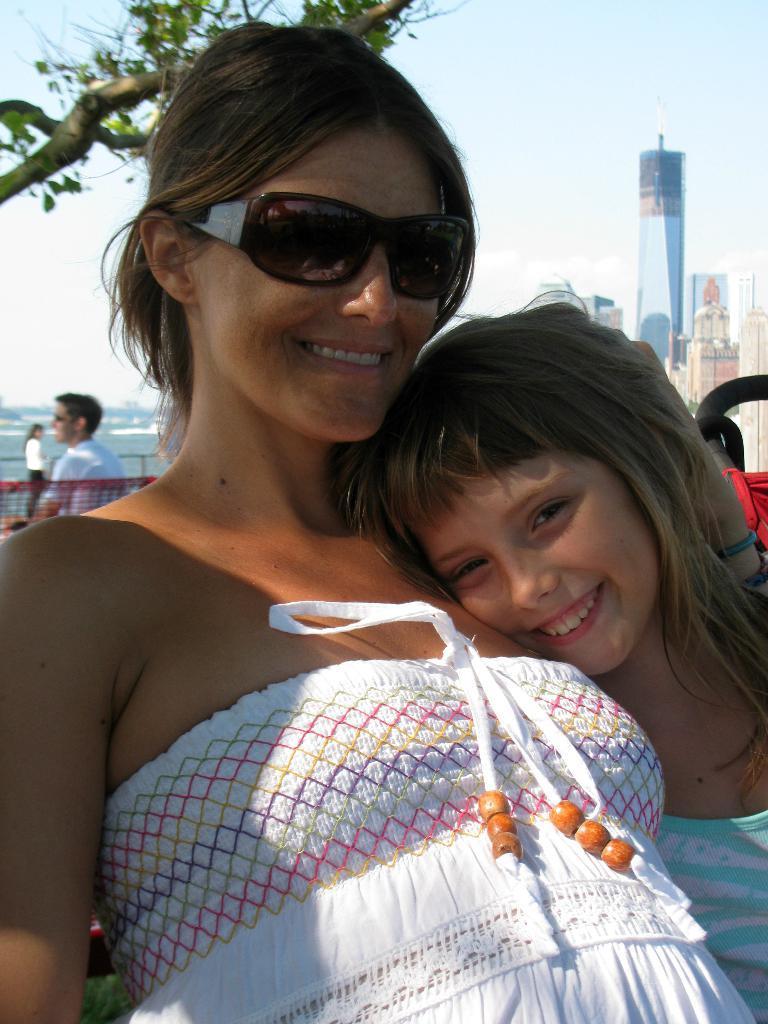In one or two sentences, can you explain what this image depicts? Here there is woman and a child, these are buildings, this is tree. 